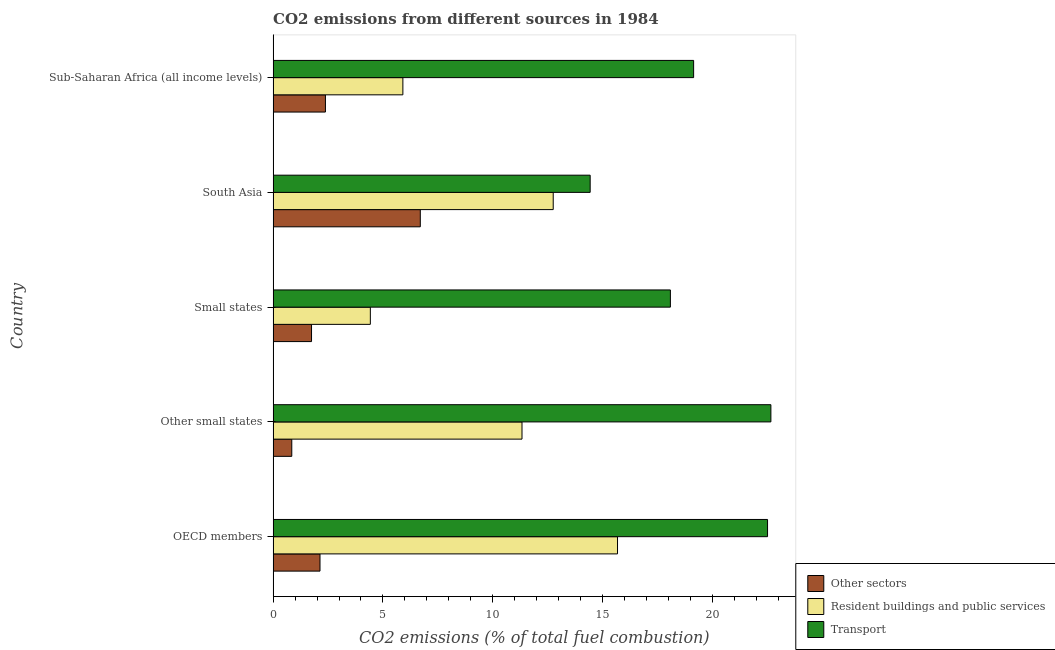How many different coloured bars are there?
Provide a succinct answer. 3. How many groups of bars are there?
Keep it short and to the point. 5. How many bars are there on the 1st tick from the top?
Offer a very short reply. 3. How many bars are there on the 4th tick from the bottom?
Provide a succinct answer. 3. What is the label of the 3rd group of bars from the top?
Provide a short and direct response. Small states. In how many cases, is the number of bars for a given country not equal to the number of legend labels?
Your answer should be very brief. 0. What is the percentage of co2 emissions from resident buildings and public services in Sub-Saharan Africa (all income levels)?
Your response must be concise. 5.91. Across all countries, what is the maximum percentage of co2 emissions from other sectors?
Provide a short and direct response. 6.7. Across all countries, what is the minimum percentage of co2 emissions from other sectors?
Offer a very short reply. 0.85. What is the total percentage of co2 emissions from resident buildings and public services in the graph?
Keep it short and to the point. 50.1. What is the difference between the percentage of co2 emissions from resident buildings and public services in Small states and that in South Asia?
Provide a succinct answer. -8.33. What is the difference between the percentage of co2 emissions from transport in South Asia and the percentage of co2 emissions from resident buildings and public services in Other small states?
Your answer should be very brief. 3.1. What is the average percentage of co2 emissions from resident buildings and public services per country?
Make the answer very short. 10.02. What is the difference between the percentage of co2 emissions from other sectors and percentage of co2 emissions from resident buildings and public services in Small states?
Give a very brief answer. -2.68. In how many countries, is the percentage of co2 emissions from resident buildings and public services greater than 19 %?
Provide a succinct answer. 0. What is the ratio of the percentage of co2 emissions from transport in Other small states to that in South Asia?
Make the answer very short. 1.57. Is the percentage of co2 emissions from other sectors in OECD members less than that in Other small states?
Provide a succinct answer. No. Is the difference between the percentage of co2 emissions from other sectors in OECD members and Other small states greater than the difference between the percentage of co2 emissions from transport in OECD members and Other small states?
Your answer should be very brief. Yes. What is the difference between the highest and the second highest percentage of co2 emissions from transport?
Your answer should be compact. 0.15. What is the difference between the highest and the lowest percentage of co2 emissions from resident buildings and public services?
Keep it short and to the point. 11.25. In how many countries, is the percentage of co2 emissions from resident buildings and public services greater than the average percentage of co2 emissions from resident buildings and public services taken over all countries?
Offer a very short reply. 3. What does the 2nd bar from the top in South Asia represents?
Offer a very short reply. Resident buildings and public services. What does the 2nd bar from the bottom in OECD members represents?
Ensure brevity in your answer.  Resident buildings and public services. Is it the case that in every country, the sum of the percentage of co2 emissions from other sectors and percentage of co2 emissions from resident buildings and public services is greater than the percentage of co2 emissions from transport?
Make the answer very short. No. Are all the bars in the graph horizontal?
Provide a succinct answer. Yes. Are the values on the major ticks of X-axis written in scientific E-notation?
Ensure brevity in your answer.  No. Does the graph contain any zero values?
Offer a terse response. No. How are the legend labels stacked?
Offer a very short reply. Vertical. What is the title of the graph?
Offer a very short reply. CO2 emissions from different sources in 1984. Does "Other sectors" appear as one of the legend labels in the graph?
Offer a very short reply. Yes. What is the label or title of the X-axis?
Your answer should be very brief. CO2 emissions (% of total fuel combustion). What is the CO2 emissions (% of total fuel combustion) in Other sectors in OECD members?
Give a very brief answer. 2.13. What is the CO2 emissions (% of total fuel combustion) of Resident buildings and public services in OECD members?
Your response must be concise. 15.68. What is the CO2 emissions (% of total fuel combustion) of Transport in OECD members?
Provide a succinct answer. 22.51. What is the CO2 emissions (% of total fuel combustion) of Other sectors in Other small states?
Offer a terse response. 0.85. What is the CO2 emissions (% of total fuel combustion) in Resident buildings and public services in Other small states?
Keep it short and to the point. 11.33. What is the CO2 emissions (% of total fuel combustion) of Transport in Other small states?
Your response must be concise. 22.66. What is the CO2 emissions (% of total fuel combustion) in Other sectors in Small states?
Give a very brief answer. 1.75. What is the CO2 emissions (% of total fuel combustion) in Resident buildings and public services in Small states?
Ensure brevity in your answer.  4.43. What is the CO2 emissions (% of total fuel combustion) of Transport in Small states?
Keep it short and to the point. 18.09. What is the CO2 emissions (% of total fuel combustion) of Other sectors in South Asia?
Provide a succinct answer. 6.7. What is the CO2 emissions (% of total fuel combustion) in Resident buildings and public services in South Asia?
Make the answer very short. 12.75. What is the CO2 emissions (% of total fuel combustion) in Transport in South Asia?
Provide a succinct answer. 14.44. What is the CO2 emissions (% of total fuel combustion) in Other sectors in Sub-Saharan Africa (all income levels)?
Provide a succinct answer. 2.38. What is the CO2 emissions (% of total fuel combustion) in Resident buildings and public services in Sub-Saharan Africa (all income levels)?
Keep it short and to the point. 5.91. What is the CO2 emissions (% of total fuel combustion) in Transport in Sub-Saharan Africa (all income levels)?
Offer a very short reply. 19.15. Across all countries, what is the maximum CO2 emissions (% of total fuel combustion) in Other sectors?
Your response must be concise. 6.7. Across all countries, what is the maximum CO2 emissions (% of total fuel combustion) in Resident buildings and public services?
Keep it short and to the point. 15.68. Across all countries, what is the maximum CO2 emissions (% of total fuel combustion) of Transport?
Provide a succinct answer. 22.66. Across all countries, what is the minimum CO2 emissions (% of total fuel combustion) of Other sectors?
Keep it short and to the point. 0.85. Across all countries, what is the minimum CO2 emissions (% of total fuel combustion) in Resident buildings and public services?
Provide a short and direct response. 4.43. Across all countries, what is the minimum CO2 emissions (% of total fuel combustion) in Transport?
Make the answer very short. 14.44. What is the total CO2 emissions (% of total fuel combustion) in Other sectors in the graph?
Your response must be concise. 13.82. What is the total CO2 emissions (% of total fuel combustion) in Resident buildings and public services in the graph?
Provide a short and direct response. 50.1. What is the total CO2 emissions (% of total fuel combustion) in Transport in the graph?
Provide a succinct answer. 96.84. What is the difference between the CO2 emissions (% of total fuel combustion) of Other sectors in OECD members and that in Other small states?
Offer a very short reply. 1.28. What is the difference between the CO2 emissions (% of total fuel combustion) of Resident buildings and public services in OECD members and that in Other small states?
Your answer should be compact. 4.35. What is the difference between the CO2 emissions (% of total fuel combustion) in Transport in OECD members and that in Other small states?
Provide a short and direct response. -0.15. What is the difference between the CO2 emissions (% of total fuel combustion) of Other sectors in OECD members and that in Small states?
Ensure brevity in your answer.  0.39. What is the difference between the CO2 emissions (% of total fuel combustion) in Resident buildings and public services in OECD members and that in Small states?
Ensure brevity in your answer.  11.25. What is the difference between the CO2 emissions (% of total fuel combustion) in Transport in OECD members and that in Small states?
Provide a succinct answer. 4.42. What is the difference between the CO2 emissions (% of total fuel combustion) of Other sectors in OECD members and that in South Asia?
Provide a succinct answer. -4.57. What is the difference between the CO2 emissions (% of total fuel combustion) in Resident buildings and public services in OECD members and that in South Asia?
Offer a terse response. 2.93. What is the difference between the CO2 emissions (% of total fuel combustion) in Transport in OECD members and that in South Asia?
Offer a terse response. 8.08. What is the difference between the CO2 emissions (% of total fuel combustion) in Other sectors in OECD members and that in Sub-Saharan Africa (all income levels)?
Provide a succinct answer. -0.25. What is the difference between the CO2 emissions (% of total fuel combustion) in Resident buildings and public services in OECD members and that in Sub-Saharan Africa (all income levels)?
Keep it short and to the point. 9.77. What is the difference between the CO2 emissions (% of total fuel combustion) in Transport in OECD members and that in Sub-Saharan Africa (all income levels)?
Ensure brevity in your answer.  3.37. What is the difference between the CO2 emissions (% of total fuel combustion) in Other sectors in Other small states and that in Small states?
Ensure brevity in your answer.  -0.9. What is the difference between the CO2 emissions (% of total fuel combustion) of Resident buildings and public services in Other small states and that in Small states?
Offer a very short reply. 6.91. What is the difference between the CO2 emissions (% of total fuel combustion) in Transport in Other small states and that in Small states?
Your answer should be very brief. 4.58. What is the difference between the CO2 emissions (% of total fuel combustion) of Other sectors in Other small states and that in South Asia?
Offer a very short reply. -5.85. What is the difference between the CO2 emissions (% of total fuel combustion) in Resident buildings and public services in Other small states and that in South Asia?
Your response must be concise. -1.42. What is the difference between the CO2 emissions (% of total fuel combustion) of Transport in Other small states and that in South Asia?
Your answer should be compact. 8.23. What is the difference between the CO2 emissions (% of total fuel combustion) of Other sectors in Other small states and that in Sub-Saharan Africa (all income levels)?
Your answer should be compact. -1.53. What is the difference between the CO2 emissions (% of total fuel combustion) in Resident buildings and public services in Other small states and that in Sub-Saharan Africa (all income levels)?
Provide a succinct answer. 5.42. What is the difference between the CO2 emissions (% of total fuel combustion) of Transport in Other small states and that in Sub-Saharan Africa (all income levels)?
Make the answer very short. 3.52. What is the difference between the CO2 emissions (% of total fuel combustion) of Other sectors in Small states and that in South Asia?
Your answer should be very brief. -4.95. What is the difference between the CO2 emissions (% of total fuel combustion) of Resident buildings and public services in Small states and that in South Asia?
Your answer should be very brief. -8.33. What is the difference between the CO2 emissions (% of total fuel combustion) in Transport in Small states and that in South Asia?
Keep it short and to the point. 3.65. What is the difference between the CO2 emissions (% of total fuel combustion) of Other sectors in Small states and that in Sub-Saharan Africa (all income levels)?
Your response must be concise. -0.63. What is the difference between the CO2 emissions (% of total fuel combustion) of Resident buildings and public services in Small states and that in Sub-Saharan Africa (all income levels)?
Make the answer very short. -1.48. What is the difference between the CO2 emissions (% of total fuel combustion) in Transport in Small states and that in Sub-Saharan Africa (all income levels)?
Provide a short and direct response. -1.06. What is the difference between the CO2 emissions (% of total fuel combustion) of Other sectors in South Asia and that in Sub-Saharan Africa (all income levels)?
Provide a succinct answer. 4.32. What is the difference between the CO2 emissions (% of total fuel combustion) of Resident buildings and public services in South Asia and that in Sub-Saharan Africa (all income levels)?
Keep it short and to the point. 6.84. What is the difference between the CO2 emissions (% of total fuel combustion) in Transport in South Asia and that in Sub-Saharan Africa (all income levels)?
Offer a terse response. -4.71. What is the difference between the CO2 emissions (% of total fuel combustion) of Other sectors in OECD members and the CO2 emissions (% of total fuel combustion) of Resident buildings and public services in Other small states?
Your answer should be very brief. -9.2. What is the difference between the CO2 emissions (% of total fuel combustion) in Other sectors in OECD members and the CO2 emissions (% of total fuel combustion) in Transport in Other small states?
Your answer should be very brief. -20.53. What is the difference between the CO2 emissions (% of total fuel combustion) in Resident buildings and public services in OECD members and the CO2 emissions (% of total fuel combustion) in Transport in Other small states?
Your response must be concise. -6.98. What is the difference between the CO2 emissions (% of total fuel combustion) of Other sectors in OECD members and the CO2 emissions (% of total fuel combustion) of Resident buildings and public services in Small states?
Your answer should be compact. -2.29. What is the difference between the CO2 emissions (% of total fuel combustion) in Other sectors in OECD members and the CO2 emissions (% of total fuel combustion) in Transport in Small states?
Make the answer very short. -15.95. What is the difference between the CO2 emissions (% of total fuel combustion) of Resident buildings and public services in OECD members and the CO2 emissions (% of total fuel combustion) of Transport in Small states?
Ensure brevity in your answer.  -2.41. What is the difference between the CO2 emissions (% of total fuel combustion) in Other sectors in OECD members and the CO2 emissions (% of total fuel combustion) in Resident buildings and public services in South Asia?
Your answer should be very brief. -10.62. What is the difference between the CO2 emissions (% of total fuel combustion) in Other sectors in OECD members and the CO2 emissions (% of total fuel combustion) in Transport in South Asia?
Give a very brief answer. -12.3. What is the difference between the CO2 emissions (% of total fuel combustion) in Resident buildings and public services in OECD members and the CO2 emissions (% of total fuel combustion) in Transport in South Asia?
Offer a very short reply. 1.25. What is the difference between the CO2 emissions (% of total fuel combustion) in Other sectors in OECD members and the CO2 emissions (% of total fuel combustion) in Resident buildings and public services in Sub-Saharan Africa (all income levels)?
Provide a succinct answer. -3.77. What is the difference between the CO2 emissions (% of total fuel combustion) in Other sectors in OECD members and the CO2 emissions (% of total fuel combustion) in Transport in Sub-Saharan Africa (all income levels)?
Keep it short and to the point. -17.01. What is the difference between the CO2 emissions (% of total fuel combustion) of Resident buildings and public services in OECD members and the CO2 emissions (% of total fuel combustion) of Transport in Sub-Saharan Africa (all income levels)?
Your answer should be very brief. -3.47. What is the difference between the CO2 emissions (% of total fuel combustion) in Other sectors in Other small states and the CO2 emissions (% of total fuel combustion) in Resident buildings and public services in Small states?
Your answer should be very brief. -3.58. What is the difference between the CO2 emissions (% of total fuel combustion) in Other sectors in Other small states and the CO2 emissions (% of total fuel combustion) in Transport in Small states?
Provide a succinct answer. -17.24. What is the difference between the CO2 emissions (% of total fuel combustion) of Resident buildings and public services in Other small states and the CO2 emissions (% of total fuel combustion) of Transport in Small states?
Offer a terse response. -6.76. What is the difference between the CO2 emissions (% of total fuel combustion) in Other sectors in Other small states and the CO2 emissions (% of total fuel combustion) in Resident buildings and public services in South Asia?
Give a very brief answer. -11.9. What is the difference between the CO2 emissions (% of total fuel combustion) in Other sectors in Other small states and the CO2 emissions (% of total fuel combustion) in Transport in South Asia?
Your answer should be very brief. -13.59. What is the difference between the CO2 emissions (% of total fuel combustion) of Resident buildings and public services in Other small states and the CO2 emissions (% of total fuel combustion) of Transport in South Asia?
Offer a terse response. -3.1. What is the difference between the CO2 emissions (% of total fuel combustion) in Other sectors in Other small states and the CO2 emissions (% of total fuel combustion) in Resident buildings and public services in Sub-Saharan Africa (all income levels)?
Make the answer very short. -5.06. What is the difference between the CO2 emissions (% of total fuel combustion) of Other sectors in Other small states and the CO2 emissions (% of total fuel combustion) of Transport in Sub-Saharan Africa (all income levels)?
Your answer should be very brief. -18.3. What is the difference between the CO2 emissions (% of total fuel combustion) in Resident buildings and public services in Other small states and the CO2 emissions (% of total fuel combustion) in Transport in Sub-Saharan Africa (all income levels)?
Give a very brief answer. -7.81. What is the difference between the CO2 emissions (% of total fuel combustion) of Other sectors in Small states and the CO2 emissions (% of total fuel combustion) of Resident buildings and public services in South Asia?
Keep it short and to the point. -11. What is the difference between the CO2 emissions (% of total fuel combustion) of Other sectors in Small states and the CO2 emissions (% of total fuel combustion) of Transport in South Asia?
Provide a succinct answer. -12.69. What is the difference between the CO2 emissions (% of total fuel combustion) of Resident buildings and public services in Small states and the CO2 emissions (% of total fuel combustion) of Transport in South Asia?
Ensure brevity in your answer.  -10.01. What is the difference between the CO2 emissions (% of total fuel combustion) in Other sectors in Small states and the CO2 emissions (% of total fuel combustion) in Resident buildings and public services in Sub-Saharan Africa (all income levels)?
Provide a short and direct response. -4.16. What is the difference between the CO2 emissions (% of total fuel combustion) of Other sectors in Small states and the CO2 emissions (% of total fuel combustion) of Transport in Sub-Saharan Africa (all income levels)?
Provide a succinct answer. -17.4. What is the difference between the CO2 emissions (% of total fuel combustion) of Resident buildings and public services in Small states and the CO2 emissions (% of total fuel combustion) of Transport in Sub-Saharan Africa (all income levels)?
Keep it short and to the point. -14.72. What is the difference between the CO2 emissions (% of total fuel combustion) of Other sectors in South Asia and the CO2 emissions (% of total fuel combustion) of Resident buildings and public services in Sub-Saharan Africa (all income levels)?
Offer a very short reply. 0.79. What is the difference between the CO2 emissions (% of total fuel combustion) of Other sectors in South Asia and the CO2 emissions (% of total fuel combustion) of Transport in Sub-Saharan Africa (all income levels)?
Your answer should be compact. -12.45. What is the difference between the CO2 emissions (% of total fuel combustion) of Resident buildings and public services in South Asia and the CO2 emissions (% of total fuel combustion) of Transport in Sub-Saharan Africa (all income levels)?
Your answer should be very brief. -6.39. What is the average CO2 emissions (% of total fuel combustion) of Other sectors per country?
Ensure brevity in your answer.  2.76. What is the average CO2 emissions (% of total fuel combustion) in Resident buildings and public services per country?
Your response must be concise. 10.02. What is the average CO2 emissions (% of total fuel combustion) of Transport per country?
Keep it short and to the point. 19.37. What is the difference between the CO2 emissions (% of total fuel combustion) of Other sectors and CO2 emissions (% of total fuel combustion) of Resident buildings and public services in OECD members?
Keep it short and to the point. -13.55. What is the difference between the CO2 emissions (% of total fuel combustion) in Other sectors and CO2 emissions (% of total fuel combustion) in Transport in OECD members?
Provide a short and direct response. -20.38. What is the difference between the CO2 emissions (% of total fuel combustion) of Resident buildings and public services and CO2 emissions (% of total fuel combustion) of Transport in OECD members?
Your answer should be very brief. -6.83. What is the difference between the CO2 emissions (% of total fuel combustion) in Other sectors and CO2 emissions (% of total fuel combustion) in Resident buildings and public services in Other small states?
Ensure brevity in your answer.  -10.48. What is the difference between the CO2 emissions (% of total fuel combustion) of Other sectors and CO2 emissions (% of total fuel combustion) of Transport in Other small states?
Provide a short and direct response. -21.81. What is the difference between the CO2 emissions (% of total fuel combustion) in Resident buildings and public services and CO2 emissions (% of total fuel combustion) in Transport in Other small states?
Your answer should be compact. -11.33. What is the difference between the CO2 emissions (% of total fuel combustion) in Other sectors and CO2 emissions (% of total fuel combustion) in Resident buildings and public services in Small states?
Keep it short and to the point. -2.68. What is the difference between the CO2 emissions (% of total fuel combustion) in Other sectors and CO2 emissions (% of total fuel combustion) in Transport in Small states?
Keep it short and to the point. -16.34. What is the difference between the CO2 emissions (% of total fuel combustion) in Resident buildings and public services and CO2 emissions (% of total fuel combustion) in Transport in Small states?
Keep it short and to the point. -13.66. What is the difference between the CO2 emissions (% of total fuel combustion) in Other sectors and CO2 emissions (% of total fuel combustion) in Resident buildings and public services in South Asia?
Ensure brevity in your answer.  -6.05. What is the difference between the CO2 emissions (% of total fuel combustion) in Other sectors and CO2 emissions (% of total fuel combustion) in Transport in South Asia?
Your answer should be compact. -7.73. What is the difference between the CO2 emissions (% of total fuel combustion) in Resident buildings and public services and CO2 emissions (% of total fuel combustion) in Transport in South Asia?
Give a very brief answer. -1.68. What is the difference between the CO2 emissions (% of total fuel combustion) in Other sectors and CO2 emissions (% of total fuel combustion) in Resident buildings and public services in Sub-Saharan Africa (all income levels)?
Provide a succinct answer. -3.53. What is the difference between the CO2 emissions (% of total fuel combustion) in Other sectors and CO2 emissions (% of total fuel combustion) in Transport in Sub-Saharan Africa (all income levels)?
Ensure brevity in your answer.  -16.76. What is the difference between the CO2 emissions (% of total fuel combustion) of Resident buildings and public services and CO2 emissions (% of total fuel combustion) of Transport in Sub-Saharan Africa (all income levels)?
Your answer should be very brief. -13.24. What is the ratio of the CO2 emissions (% of total fuel combustion) in Other sectors in OECD members to that in Other small states?
Offer a very short reply. 2.51. What is the ratio of the CO2 emissions (% of total fuel combustion) in Resident buildings and public services in OECD members to that in Other small states?
Your answer should be compact. 1.38. What is the ratio of the CO2 emissions (% of total fuel combustion) in Transport in OECD members to that in Other small states?
Offer a very short reply. 0.99. What is the ratio of the CO2 emissions (% of total fuel combustion) of Other sectors in OECD members to that in Small states?
Your answer should be compact. 1.22. What is the ratio of the CO2 emissions (% of total fuel combustion) of Resident buildings and public services in OECD members to that in Small states?
Keep it short and to the point. 3.54. What is the ratio of the CO2 emissions (% of total fuel combustion) of Transport in OECD members to that in Small states?
Offer a very short reply. 1.24. What is the ratio of the CO2 emissions (% of total fuel combustion) of Other sectors in OECD members to that in South Asia?
Provide a succinct answer. 0.32. What is the ratio of the CO2 emissions (% of total fuel combustion) in Resident buildings and public services in OECD members to that in South Asia?
Your response must be concise. 1.23. What is the ratio of the CO2 emissions (% of total fuel combustion) of Transport in OECD members to that in South Asia?
Provide a short and direct response. 1.56. What is the ratio of the CO2 emissions (% of total fuel combustion) of Other sectors in OECD members to that in Sub-Saharan Africa (all income levels)?
Your answer should be very brief. 0.9. What is the ratio of the CO2 emissions (% of total fuel combustion) of Resident buildings and public services in OECD members to that in Sub-Saharan Africa (all income levels)?
Your answer should be very brief. 2.65. What is the ratio of the CO2 emissions (% of total fuel combustion) of Transport in OECD members to that in Sub-Saharan Africa (all income levels)?
Provide a short and direct response. 1.18. What is the ratio of the CO2 emissions (% of total fuel combustion) in Other sectors in Other small states to that in Small states?
Your answer should be compact. 0.49. What is the ratio of the CO2 emissions (% of total fuel combustion) in Resident buildings and public services in Other small states to that in Small states?
Your answer should be very brief. 2.56. What is the ratio of the CO2 emissions (% of total fuel combustion) of Transport in Other small states to that in Small states?
Your answer should be compact. 1.25. What is the ratio of the CO2 emissions (% of total fuel combustion) of Other sectors in Other small states to that in South Asia?
Your response must be concise. 0.13. What is the ratio of the CO2 emissions (% of total fuel combustion) of Resident buildings and public services in Other small states to that in South Asia?
Make the answer very short. 0.89. What is the ratio of the CO2 emissions (% of total fuel combustion) of Transport in Other small states to that in South Asia?
Keep it short and to the point. 1.57. What is the ratio of the CO2 emissions (% of total fuel combustion) of Other sectors in Other small states to that in Sub-Saharan Africa (all income levels)?
Keep it short and to the point. 0.36. What is the ratio of the CO2 emissions (% of total fuel combustion) in Resident buildings and public services in Other small states to that in Sub-Saharan Africa (all income levels)?
Provide a short and direct response. 1.92. What is the ratio of the CO2 emissions (% of total fuel combustion) in Transport in Other small states to that in Sub-Saharan Africa (all income levels)?
Give a very brief answer. 1.18. What is the ratio of the CO2 emissions (% of total fuel combustion) in Other sectors in Small states to that in South Asia?
Offer a terse response. 0.26. What is the ratio of the CO2 emissions (% of total fuel combustion) in Resident buildings and public services in Small states to that in South Asia?
Make the answer very short. 0.35. What is the ratio of the CO2 emissions (% of total fuel combustion) of Transport in Small states to that in South Asia?
Make the answer very short. 1.25. What is the ratio of the CO2 emissions (% of total fuel combustion) of Other sectors in Small states to that in Sub-Saharan Africa (all income levels)?
Ensure brevity in your answer.  0.73. What is the ratio of the CO2 emissions (% of total fuel combustion) in Resident buildings and public services in Small states to that in Sub-Saharan Africa (all income levels)?
Make the answer very short. 0.75. What is the ratio of the CO2 emissions (% of total fuel combustion) in Transport in Small states to that in Sub-Saharan Africa (all income levels)?
Your answer should be very brief. 0.94. What is the ratio of the CO2 emissions (% of total fuel combustion) of Other sectors in South Asia to that in Sub-Saharan Africa (all income levels)?
Offer a terse response. 2.81. What is the ratio of the CO2 emissions (% of total fuel combustion) in Resident buildings and public services in South Asia to that in Sub-Saharan Africa (all income levels)?
Provide a short and direct response. 2.16. What is the ratio of the CO2 emissions (% of total fuel combustion) of Transport in South Asia to that in Sub-Saharan Africa (all income levels)?
Your answer should be compact. 0.75. What is the difference between the highest and the second highest CO2 emissions (% of total fuel combustion) of Other sectors?
Ensure brevity in your answer.  4.32. What is the difference between the highest and the second highest CO2 emissions (% of total fuel combustion) of Resident buildings and public services?
Give a very brief answer. 2.93. What is the difference between the highest and the second highest CO2 emissions (% of total fuel combustion) of Transport?
Offer a very short reply. 0.15. What is the difference between the highest and the lowest CO2 emissions (% of total fuel combustion) of Other sectors?
Offer a very short reply. 5.85. What is the difference between the highest and the lowest CO2 emissions (% of total fuel combustion) in Resident buildings and public services?
Give a very brief answer. 11.25. What is the difference between the highest and the lowest CO2 emissions (% of total fuel combustion) in Transport?
Provide a short and direct response. 8.23. 